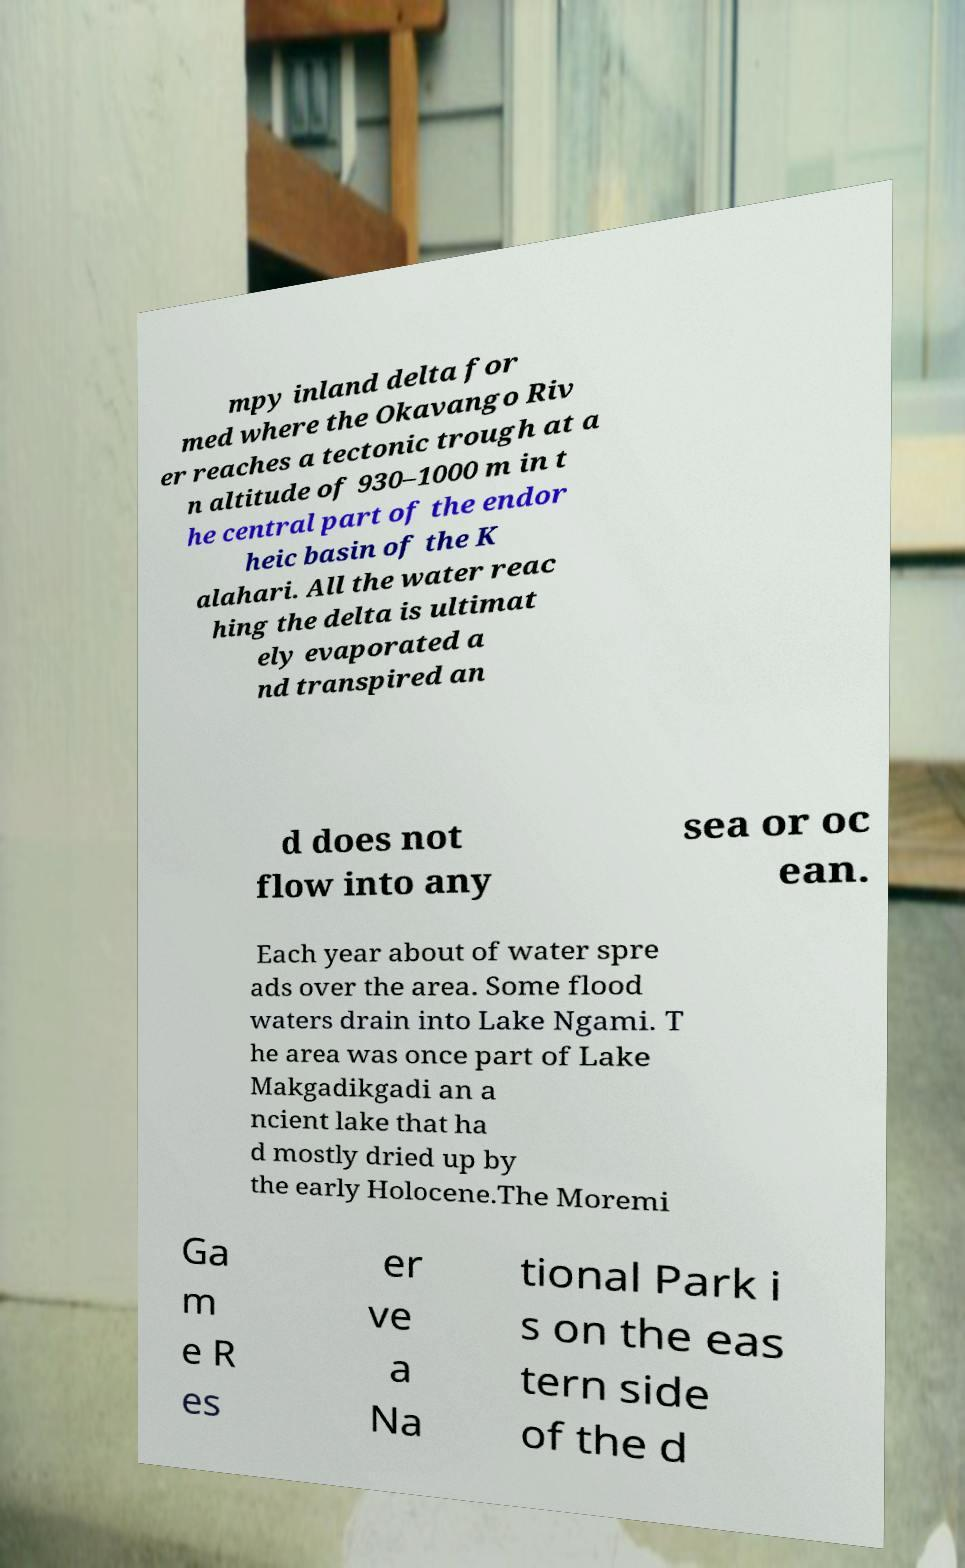I need the written content from this picture converted into text. Can you do that? mpy inland delta for med where the Okavango Riv er reaches a tectonic trough at a n altitude of 930–1000 m in t he central part of the endor heic basin of the K alahari. All the water reac hing the delta is ultimat ely evaporated a nd transpired an d does not flow into any sea or oc ean. Each year about of water spre ads over the area. Some flood waters drain into Lake Ngami. T he area was once part of Lake Makgadikgadi an a ncient lake that ha d mostly dried up by the early Holocene.The Moremi Ga m e R es er ve a Na tional Park i s on the eas tern side of the d 